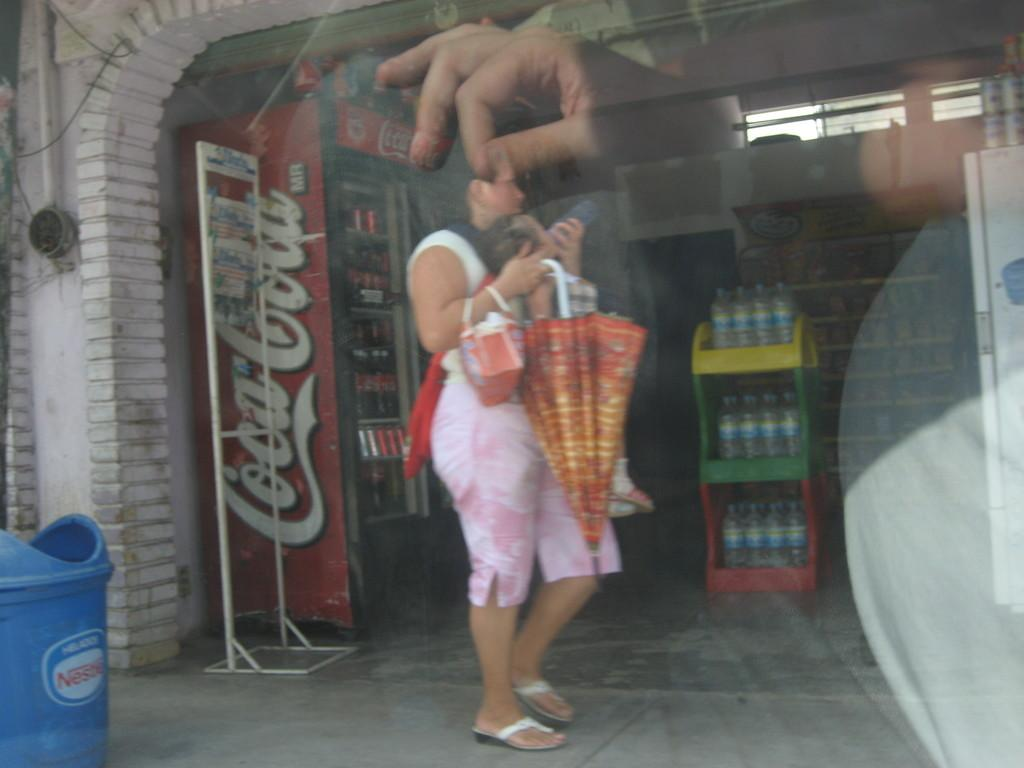<image>
Provide a brief description of the given image. A lady standing in front of a Coca Cola vending machine 